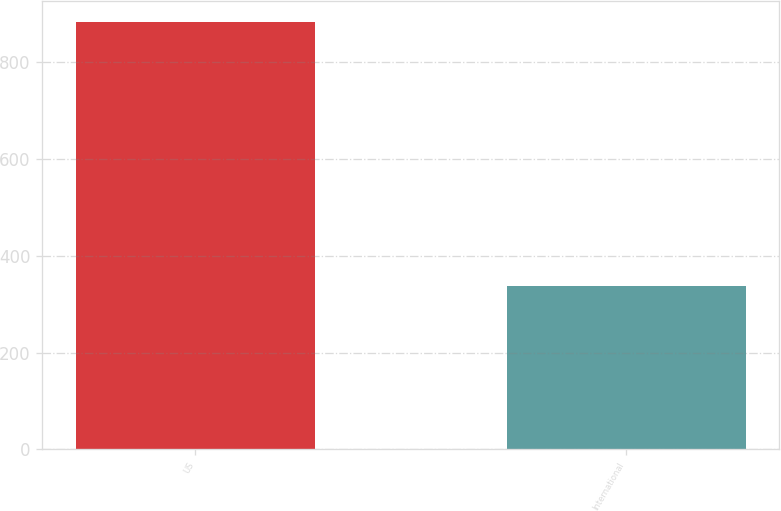Convert chart. <chart><loc_0><loc_0><loc_500><loc_500><bar_chart><fcel>US<fcel>International<nl><fcel>882<fcel>338<nl></chart> 